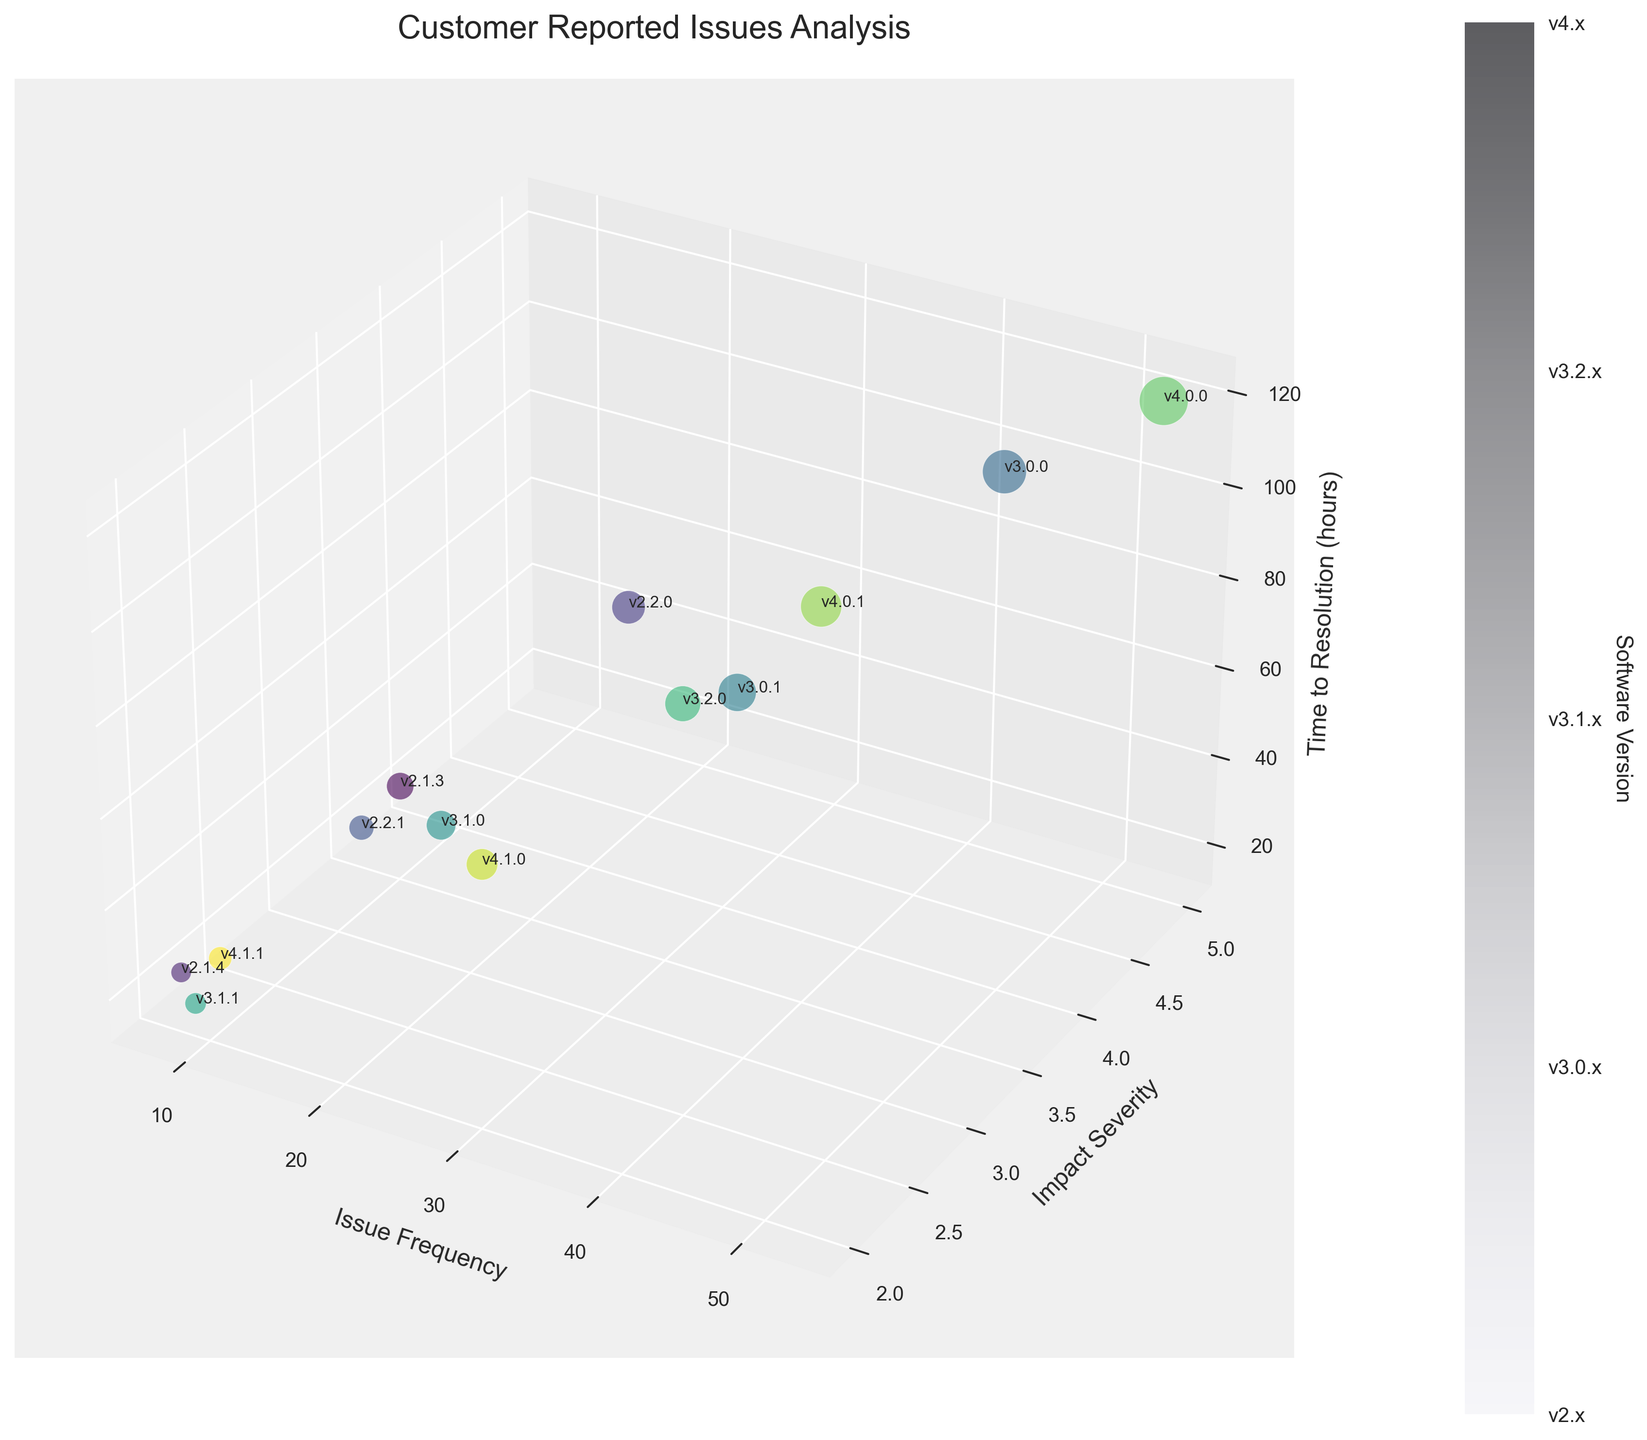What is the title of this figure? The title is usually placed prominently at the top of the figure. In this case, it states the main subject of the chart.
Answer: Customer Reported Issues Analysis What do the axes represent in this chart? The labels on each axis correspond to specific metrics being measured. From the figure, the x-axis represents 'Issue Frequency', the y-axis represents 'Impact Severity', and the z-axis represents 'Time to Resolution (hours)'.
Answer: Issue Frequency, Impact Severity, Time to Resolution (hours) How does the impact severity of v4.0.0 compare to v2.2.0? By looking at the y-axis, the position of the bubbles corresponding to these versions can be compared. The bubble for v4.0.0 is at y=5 and the bubble for v2.2.0 is at y=4, which means v4.0.0 has a higher impact severity.
Answer: v4.0.0 is higher Which software version has the highest issue frequency and what is that frequency? The x-axis represents issue frequency, so locating the bubble with the highest x-value shows the version. The bubble for v4.0.0 is furthest along the x-axis at 53.
Answer: v4.0.0, 53 What is the issue frequency range for versions in the v3.x series? This requires identifying all bubbles for the v3.x versions and noting their x-values. The smallest value is 9 (v3.1.1) and the largest is 42 (v3.0.0).
Answer: 9 to 42 Calculate the average time to resolution for v3.0.0, v3.0.1, and v3.2.0. Identify the z-values (time to resolution) for these versions: v3.0.0 (96), v3.0.1 (60), v3.2.0 (54). Add these values and divide by 3: (96 + 60 + 54) / 3 = 70.
Answer: 70 Which version has the shortest time to resolution and what is the value? The smallest z-value represents the shortest time to resolution. The version v3.1.1 has the smallest z-value at 18.
Answer: v3.1.1, 18 How do issue frequency and impact severity correlate for v4.0.0? This requires comparing the x-value (53) and y-value (5) for the bubble representing v4.0.0. High issue frequency seems to align with high impact severity for this version.
Answer: High frequency and high severity Compare the time to resolution between the first and the last version on the chart. Identify the z-values of the first (v2.1.3, 48) and the last (v4.1.1, 30). v4.1.1 has a shorter resolution time compared to v2.1.3.
Answer: v4.1.1 is shorter by 18 hours What is the pattern in the time to resolution as the software versions progress from v2.1.3 to v4.1.1? Identify the trend by observing the z-values for each version in sequence. Notice whether they generally increase, decrease, or vary irregularly. From v2.1.3 (48) to v4.0.0 (120), there is an increasing trend, with variations after.
Answer: Generally increasing with variations 